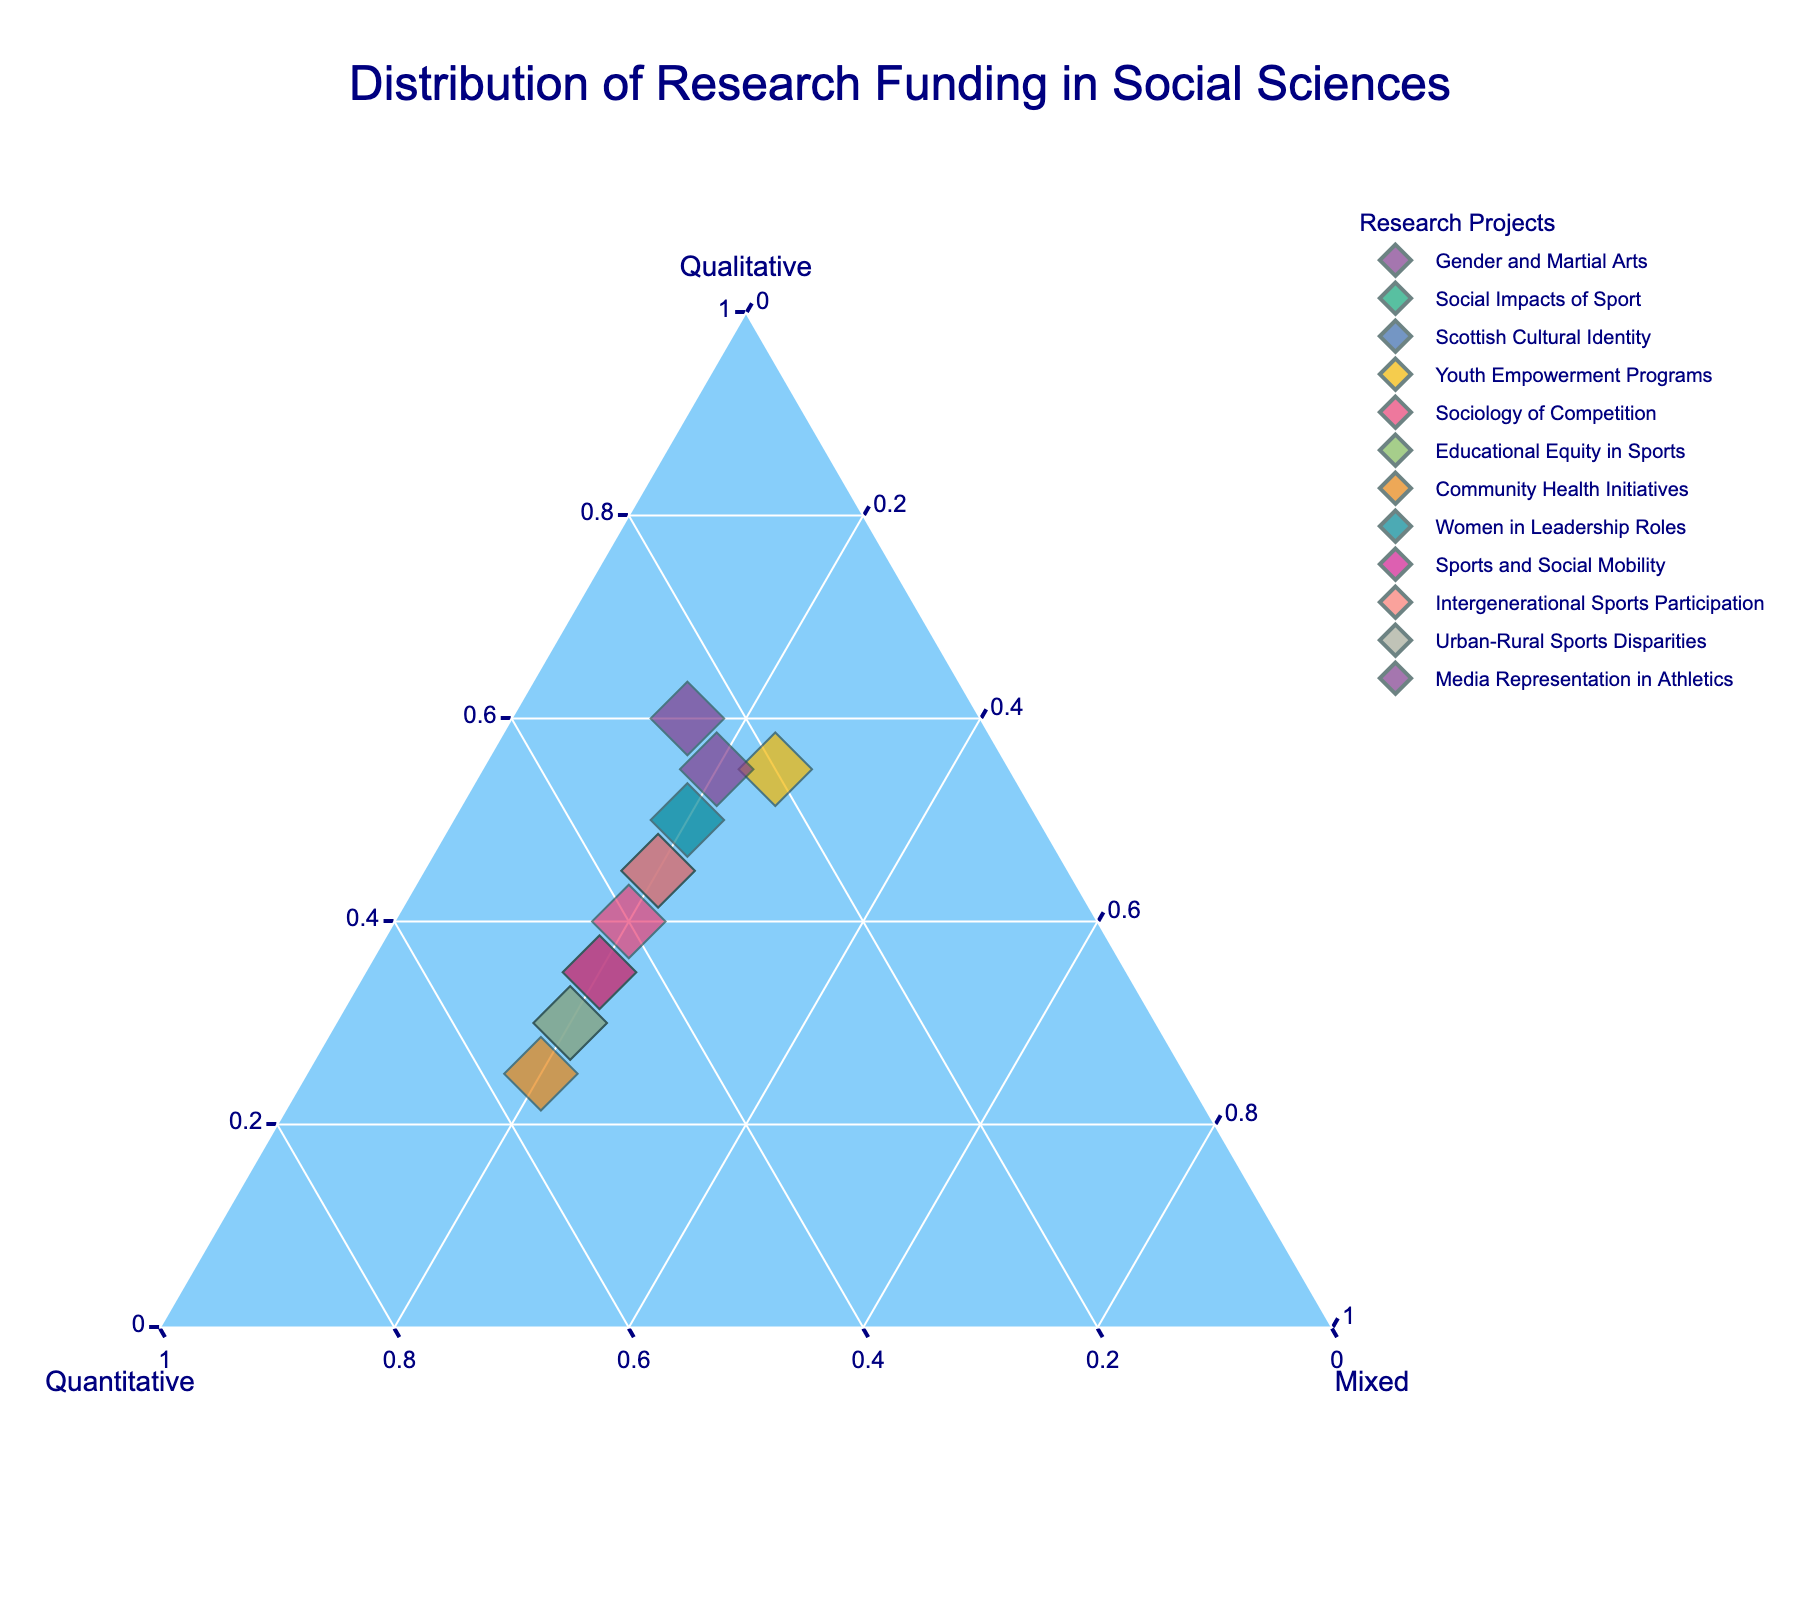What's the title of the figure? The title of the figure is prominently displayed at the top, which reads "Distribution of Research Funding in Social Sciences".
Answer: Distribution of Research Funding in Social Sciences How many research projects are represented in the plot? Each marker on the ternary plot represents a different research project. By counting these markers, we can determine the number of projects represented.
Answer: 12 Which research project has the highest proportion of qualitative funding? The ternary plot shows each project with normalized percentages. The project with the marker closest to the vertex labeled "Qualitative" has the highest proportion of qualitative funding.
Answer: Gender and Martial Arts What is the average percentage of quantitative funding across all projects? To calculate the average, sum the normalized percentages of quantitative funding for all projects and divide by the number of projects (12). (25 + 50 + 35 + 20 + 40 + 45 + 55 + 30 + 45 + 35 + 50 + 25) / 12.
Answer: 38.33% Which project has an equal proportion of quantitative and qualitative funding? The project with markers on the plot that lie on the line where the proportions of quantitative and qualitative funding are equal (i.e., the line along y = x).
Answer: Sociology of Competition Which research project has the least proportion of mixed methods funding? The ternary plot shows each project's normalized funding proportions. The project whose marker is furthest from the "Mixed" vertex has the least proportion of mixed methods funding.
Answer: Gender and Martial Arts Does any project have exactly 25% of mixed methods funding? The project whose marker is on the line indicating 25% mixed methods funding on the ternary plot confirms the required criteria.
Answer: Youth Empowerment Programs, Media Representation in Athletics Which project has more qualitative than quantitative funding but also has a non-zero mixed methods funding? Look for projects whose markers are closer to the "Qualitative" vertex than the "Quantitative" vertex, and also not lying at zero mixed funding. E.g., a project to the right of the center towards the qualitative side.
Answer: Women in Leadership Roles Compare the mixed methods funding proportions of 'Educational Equity in Sports' and 'Youth Empowerment Programs'. Which one is higher? Locate the markers for these two projects and compare their positions relative to the "Mixed" vertex.
Answer: Youth Empowerment Programs Which projects have the same proportion of Mixed methods funding? Identify the projects whose markers align on the same level towards the "Mixed" vertex.
Answer: Social Impacts of Sport, Scottish Cultural Identity, Youth Empowerment Programs, Sociology of Competition, Educational Equity in Sports, Community Health Initiatives, Women in Leadership Roles, Sports and Social Mobility, Intergenerational Sports Participation, Urban-Rural Sports Disparities, Media Representation in Athletics 